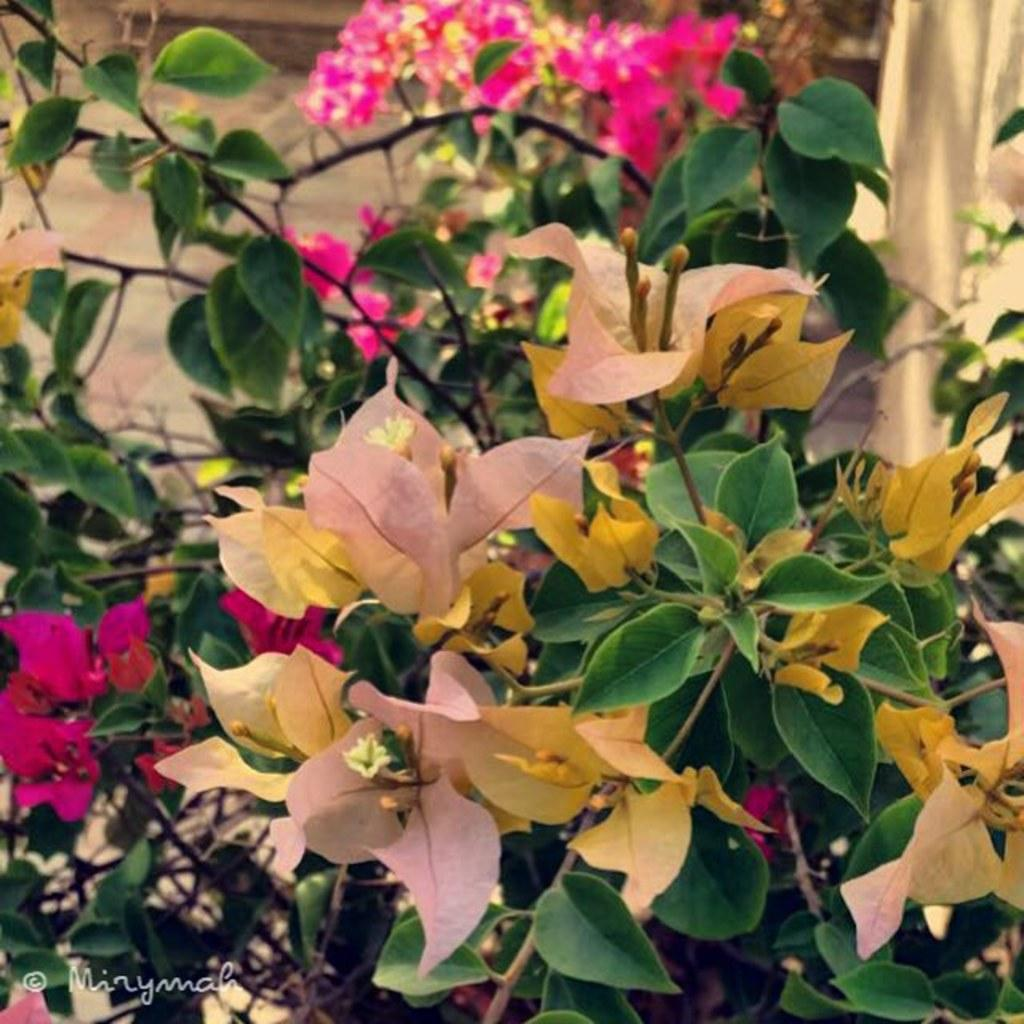What is present in the image? There is a plant in the image. What can be observed about the plant's flowers? The plant has pink-colored flowers. What is the price of the boys playing near the boundary in the image? There are no boys or boundaries present in the image; it only features a plant with pink flowers. 